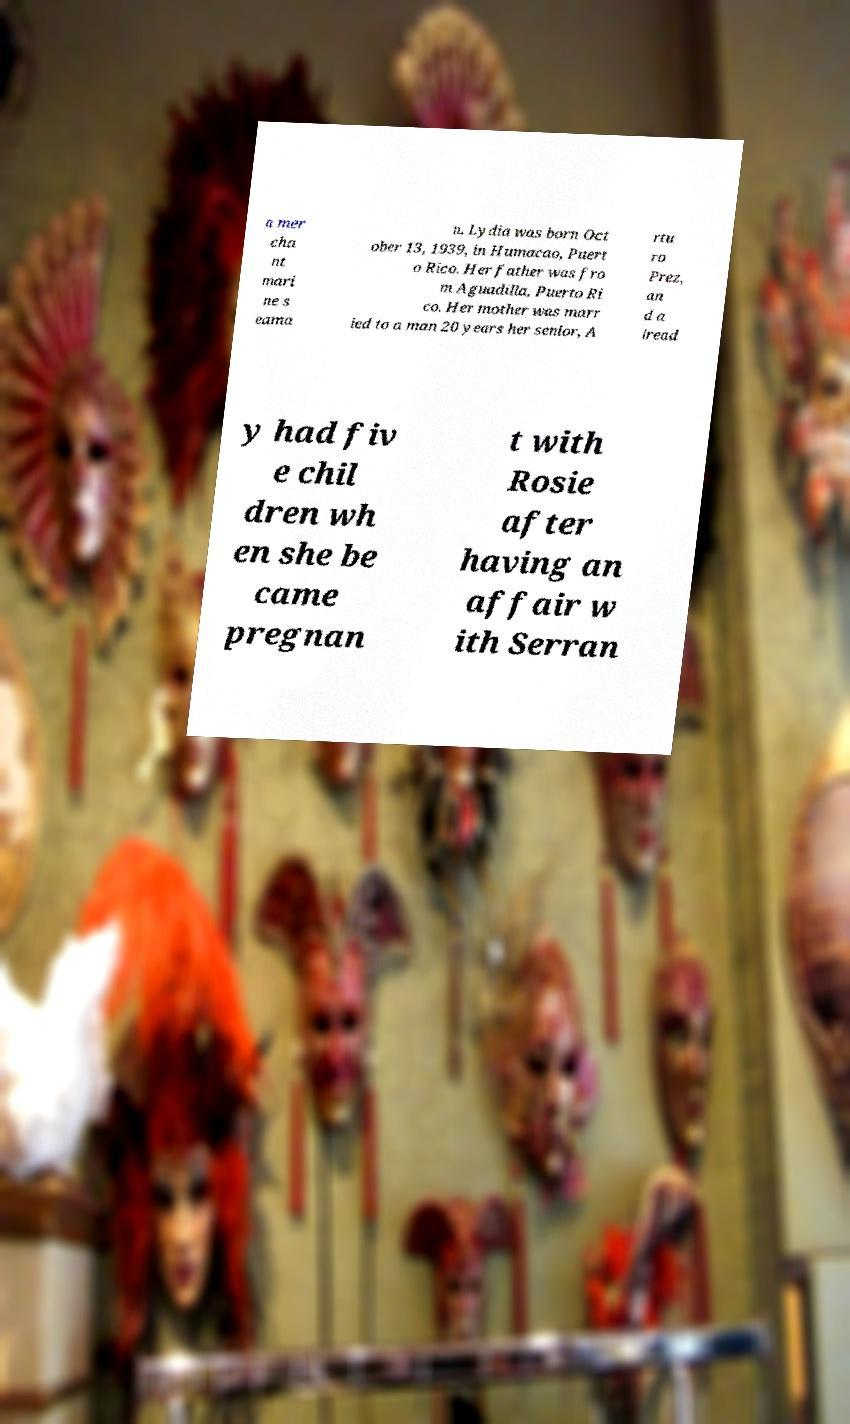There's text embedded in this image that I need extracted. Can you transcribe it verbatim? a mer cha nt mari ne s eama n. Lydia was born Oct ober 13, 1939, in Humacao, Puert o Rico. Her father was fro m Aguadilla, Puerto Ri co. Her mother was marr ied to a man 20 years her senior, A rtu ro Prez, an d a lread y had fiv e chil dren wh en she be came pregnan t with Rosie after having an affair w ith Serran 